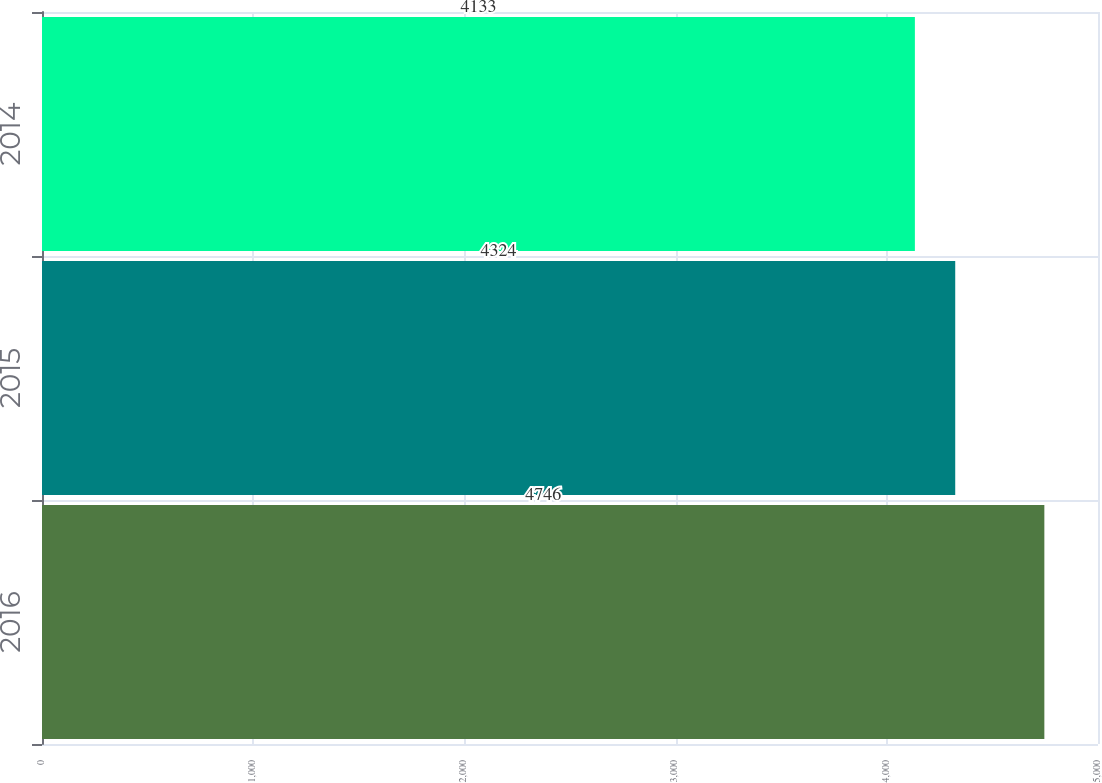<chart> <loc_0><loc_0><loc_500><loc_500><bar_chart><fcel>2016<fcel>2015<fcel>2014<nl><fcel>4746<fcel>4324<fcel>4133<nl></chart> 